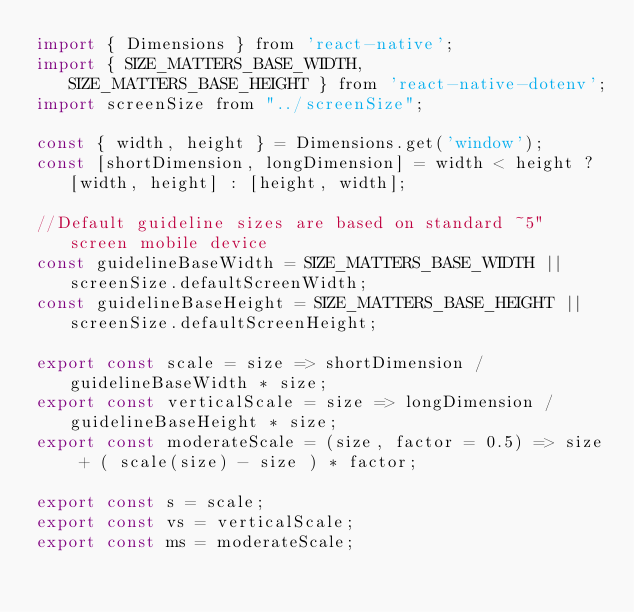Convert code to text. <code><loc_0><loc_0><loc_500><loc_500><_JavaScript_>import { Dimensions } from 'react-native';
import { SIZE_MATTERS_BASE_WIDTH, SIZE_MATTERS_BASE_HEIGHT } from 'react-native-dotenv';
import screenSize from "../screenSize";

const { width, height } = Dimensions.get('window');
const [shortDimension, longDimension] = width < height ? [width, height] : [height, width];

//Default guideline sizes are based on standard ~5" screen mobile device
const guidelineBaseWidth = SIZE_MATTERS_BASE_WIDTH || screenSize.defaultScreenWidth;
const guidelineBaseHeight = SIZE_MATTERS_BASE_HEIGHT || screenSize.defaultScreenHeight;

export const scale = size => shortDimension / guidelineBaseWidth * size;
export const verticalScale = size => longDimension / guidelineBaseHeight * size;
export const moderateScale = (size, factor = 0.5) => size + ( scale(size) - size ) * factor;

export const s = scale;
export const vs = verticalScale;
export const ms = moderateScale;
</code> 